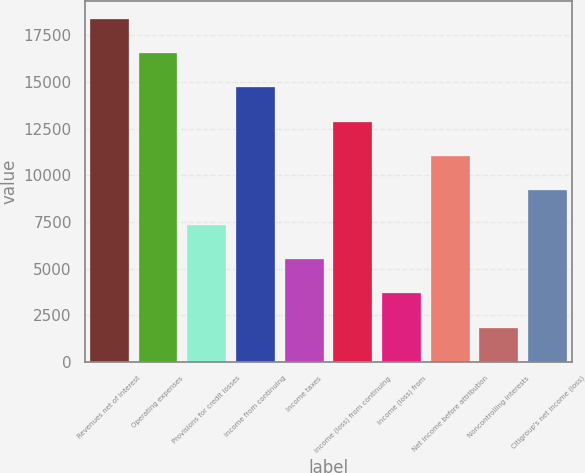Convert chart. <chart><loc_0><loc_0><loc_500><loc_500><bar_chart><fcel>Revenues net of interest<fcel>Operating expenses<fcel>Provisions for credit losses<fcel>Income from continuing<fcel>Income taxes<fcel>Income (loss) from continuing<fcel>Income (loss) from<fcel>Net income before attribution<fcel>Noncontrolling interests<fcel>Citigroup's net income (loss)<nl><fcel>18389<fcel>16550.3<fcel>7356.65<fcel>14711.6<fcel>5517.92<fcel>12872.8<fcel>3679.19<fcel>11034.1<fcel>1840.46<fcel>9195.38<nl></chart> 